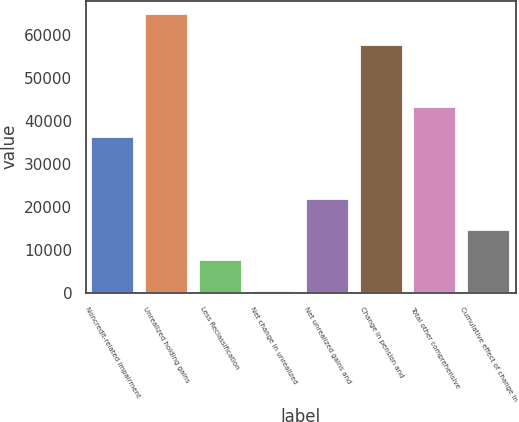Convert chart to OTSL. <chart><loc_0><loc_0><loc_500><loc_500><bar_chart><fcel>Noncredit-related impairment<fcel>Unrealized holding gains<fcel>Less Reclassification<fcel>Net change in unrealized<fcel>Net unrealized gains and<fcel>Change in pension and<fcel>Total other comprehensive<fcel>Cumulative effect of change in<nl><fcel>36210<fcel>64860.4<fcel>7559.6<fcel>397<fcel>21884.8<fcel>57697.8<fcel>43372.6<fcel>14722.2<nl></chart> 